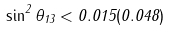<formula> <loc_0><loc_0><loc_500><loc_500>\sin ^ { 2 } \theta _ { 1 3 } < 0 . 0 1 5 ( 0 . 0 4 8 )</formula> 